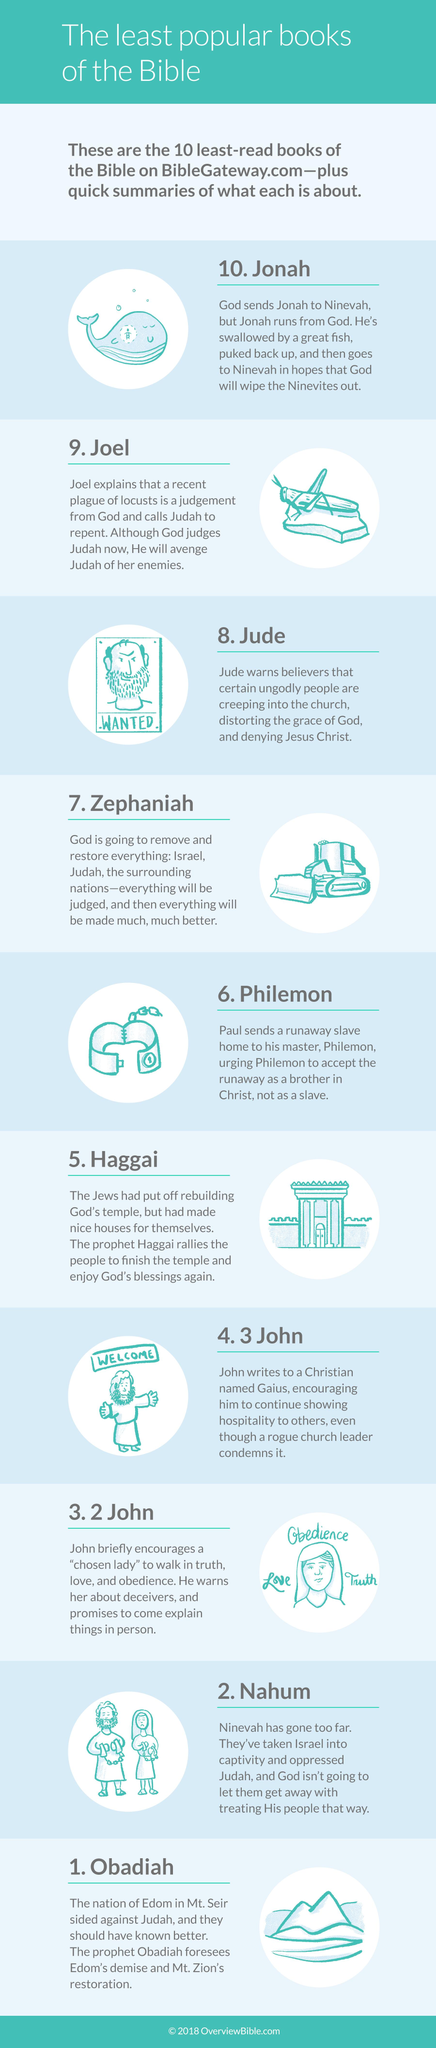Specify some key components in this picture. There are ten images in this infographic. 